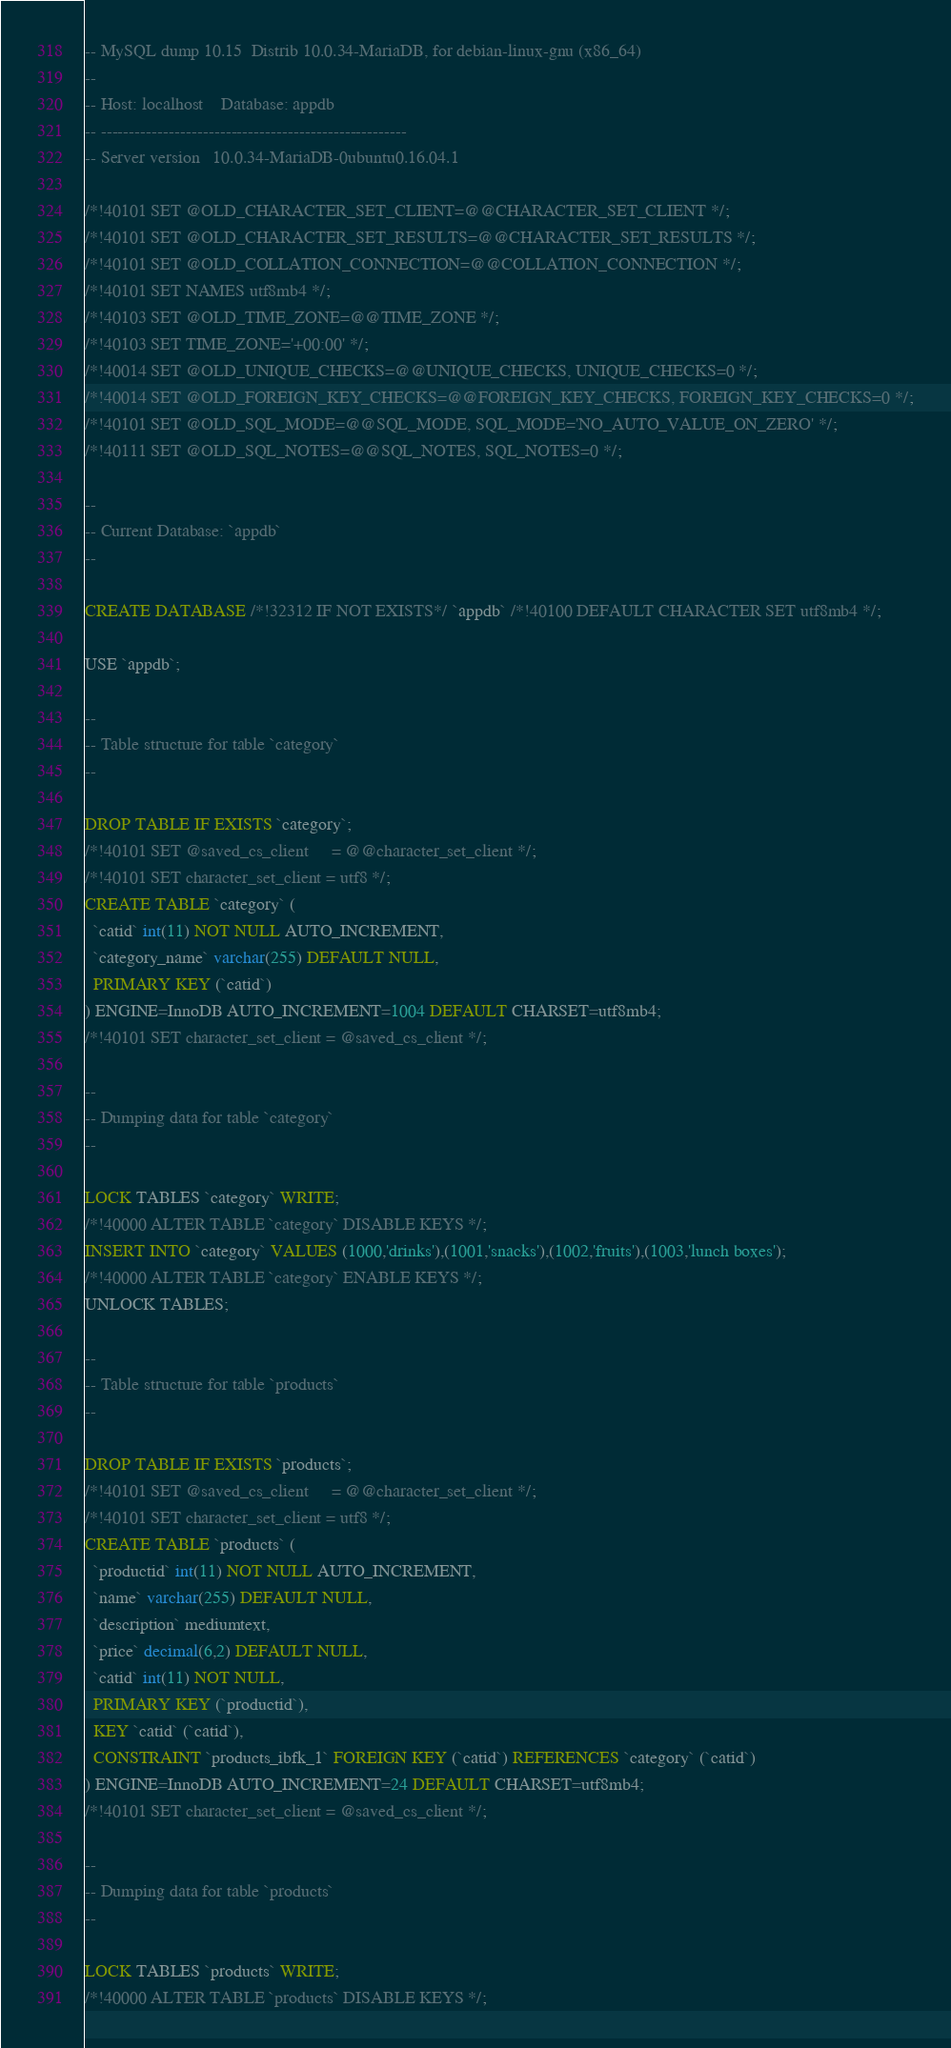Convert code to text. <code><loc_0><loc_0><loc_500><loc_500><_SQL_>-- MySQL dump 10.15  Distrib 10.0.34-MariaDB, for debian-linux-gnu (x86_64)
--
-- Host: localhost    Database: appdb
-- ------------------------------------------------------
-- Server version	10.0.34-MariaDB-0ubuntu0.16.04.1

/*!40101 SET @OLD_CHARACTER_SET_CLIENT=@@CHARACTER_SET_CLIENT */;
/*!40101 SET @OLD_CHARACTER_SET_RESULTS=@@CHARACTER_SET_RESULTS */;
/*!40101 SET @OLD_COLLATION_CONNECTION=@@COLLATION_CONNECTION */;
/*!40101 SET NAMES utf8mb4 */;
/*!40103 SET @OLD_TIME_ZONE=@@TIME_ZONE */;
/*!40103 SET TIME_ZONE='+00:00' */;
/*!40014 SET @OLD_UNIQUE_CHECKS=@@UNIQUE_CHECKS, UNIQUE_CHECKS=0 */;
/*!40014 SET @OLD_FOREIGN_KEY_CHECKS=@@FOREIGN_KEY_CHECKS, FOREIGN_KEY_CHECKS=0 */;
/*!40101 SET @OLD_SQL_MODE=@@SQL_MODE, SQL_MODE='NO_AUTO_VALUE_ON_ZERO' */;
/*!40111 SET @OLD_SQL_NOTES=@@SQL_NOTES, SQL_NOTES=0 */;

--
-- Current Database: `appdb`
--

CREATE DATABASE /*!32312 IF NOT EXISTS*/ `appdb` /*!40100 DEFAULT CHARACTER SET utf8mb4 */;

USE `appdb`;

--
-- Table structure for table `category`
--

DROP TABLE IF EXISTS `category`;
/*!40101 SET @saved_cs_client     = @@character_set_client */;
/*!40101 SET character_set_client = utf8 */;
CREATE TABLE `category` (
  `catid` int(11) NOT NULL AUTO_INCREMENT,
  `category_name` varchar(255) DEFAULT NULL,
  PRIMARY KEY (`catid`)
) ENGINE=InnoDB AUTO_INCREMENT=1004 DEFAULT CHARSET=utf8mb4;
/*!40101 SET character_set_client = @saved_cs_client */;

--
-- Dumping data for table `category`
--

LOCK TABLES `category` WRITE;
/*!40000 ALTER TABLE `category` DISABLE KEYS */;
INSERT INTO `category` VALUES (1000,'drinks'),(1001,'snacks'),(1002,'fruits'),(1003,'lunch boxes');
/*!40000 ALTER TABLE `category` ENABLE KEYS */;
UNLOCK TABLES;

--
-- Table structure for table `products`
--

DROP TABLE IF EXISTS `products`;
/*!40101 SET @saved_cs_client     = @@character_set_client */;
/*!40101 SET character_set_client = utf8 */;
CREATE TABLE `products` (
  `productid` int(11) NOT NULL AUTO_INCREMENT,
  `name` varchar(255) DEFAULT NULL,
  `description` mediumtext,
  `price` decimal(6,2) DEFAULT NULL,
  `catid` int(11) NOT NULL,
  PRIMARY KEY (`productid`),
  KEY `catid` (`catid`),
  CONSTRAINT `products_ibfk_1` FOREIGN KEY (`catid`) REFERENCES `category` (`catid`)
) ENGINE=InnoDB AUTO_INCREMENT=24 DEFAULT CHARSET=utf8mb4;
/*!40101 SET character_set_client = @saved_cs_client */;

--
-- Dumping data for table `products`
--

LOCK TABLES `products` WRITE;
/*!40000 ALTER TABLE `products` DISABLE KEYS */;</code> 